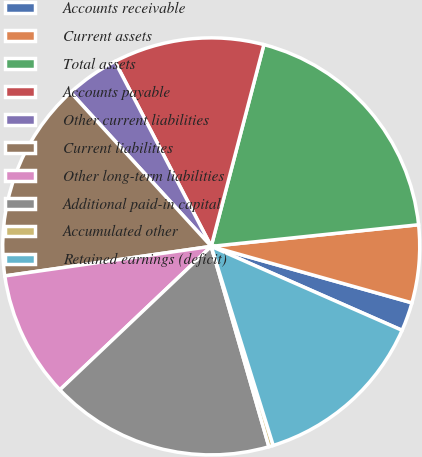Convert chart to OTSL. <chart><loc_0><loc_0><loc_500><loc_500><pie_chart><fcel>Accounts receivable<fcel>Current assets<fcel>Total assets<fcel>Accounts payable<fcel>Other current liabilities<fcel>Current liabilities<fcel>Other long-term liabilities<fcel>Additional paid-in capital<fcel>Accumulated other<fcel>Retained earnings (deficit)<nl><fcel>2.23%<fcel>6.02%<fcel>19.28%<fcel>11.71%<fcel>4.13%<fcel>15.49%<fcel>9.81%<fcel>17.39%<fcel>0.34%<fcel>13.6%<nl></chart> 